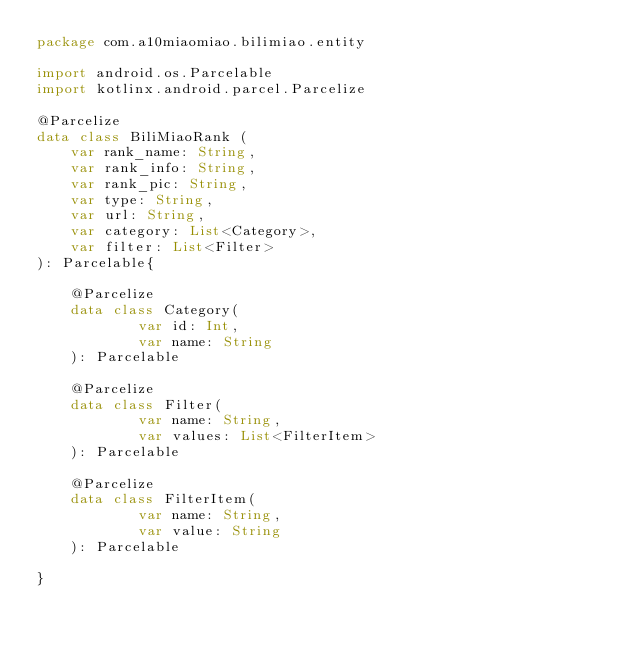Convert code to text. <code><loc_0><loc_0><loc_500><loc_500><_Kotlin_>package com.a10miaomiao.bilimiao.entity

import android.os.Parcelable
import kotlinx.android.parcel.Parcelize

@Parcelize
data class BiliMiaoRank (
    var rank_name: String,
    var rank_info: String,
    var rank_pic: String,
    var type: String,
    var url: String,
    var category: List<Category>,
    var filter: List<Filter>
): Parcelable{

    @Parcelize
    data class Category(
            var id: Int,
            var name: String
    ): Parcelable

    @Parcelize
    data class Filter(
            var name: String,
            var values: List<FilterItem>
    ): Parcelable

    @Parcelize
    data class FilterItem(
            var name: String,
            var value: String
    ): Parcelable

}</code> 